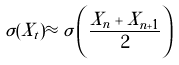<formula> <loc_0><loc_0><loc_500><loc_500>\sigma ( X _ { t } ) \approx \sigma \left ( \frac { X _ { n } + X _ { n + 1 } } { 2 } \right )</formula> 